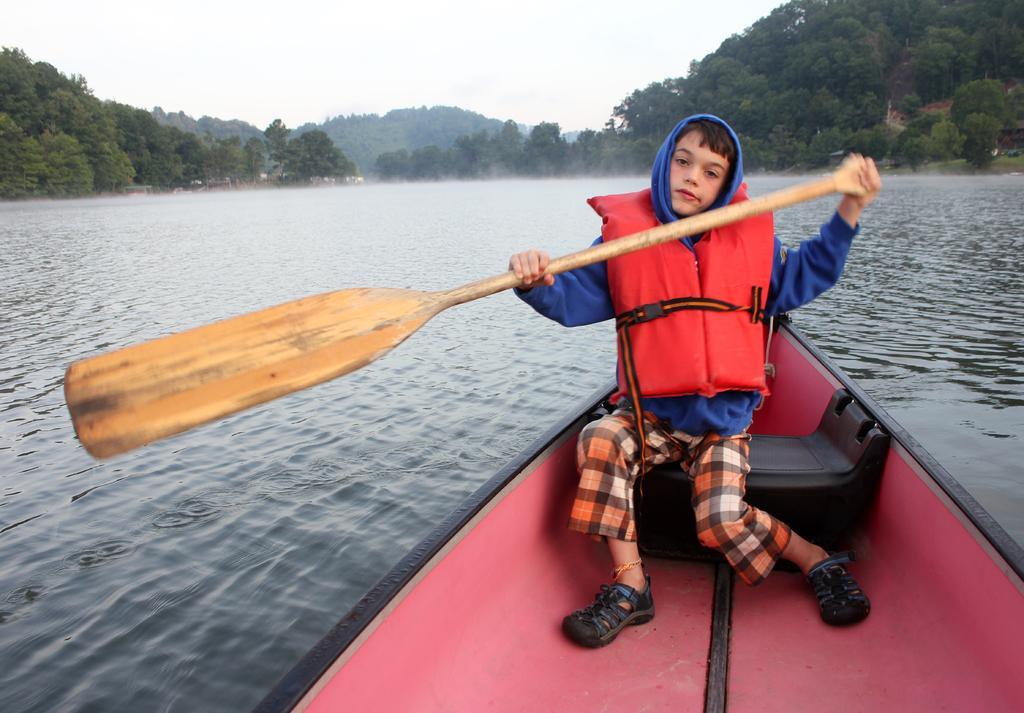Can you describe this image briefly? In the background we can see the sky and trees. In this picture we can see a boy wearing a hoodie and a life jacket, holding a paddle and sitting in a boat which is on the water. 